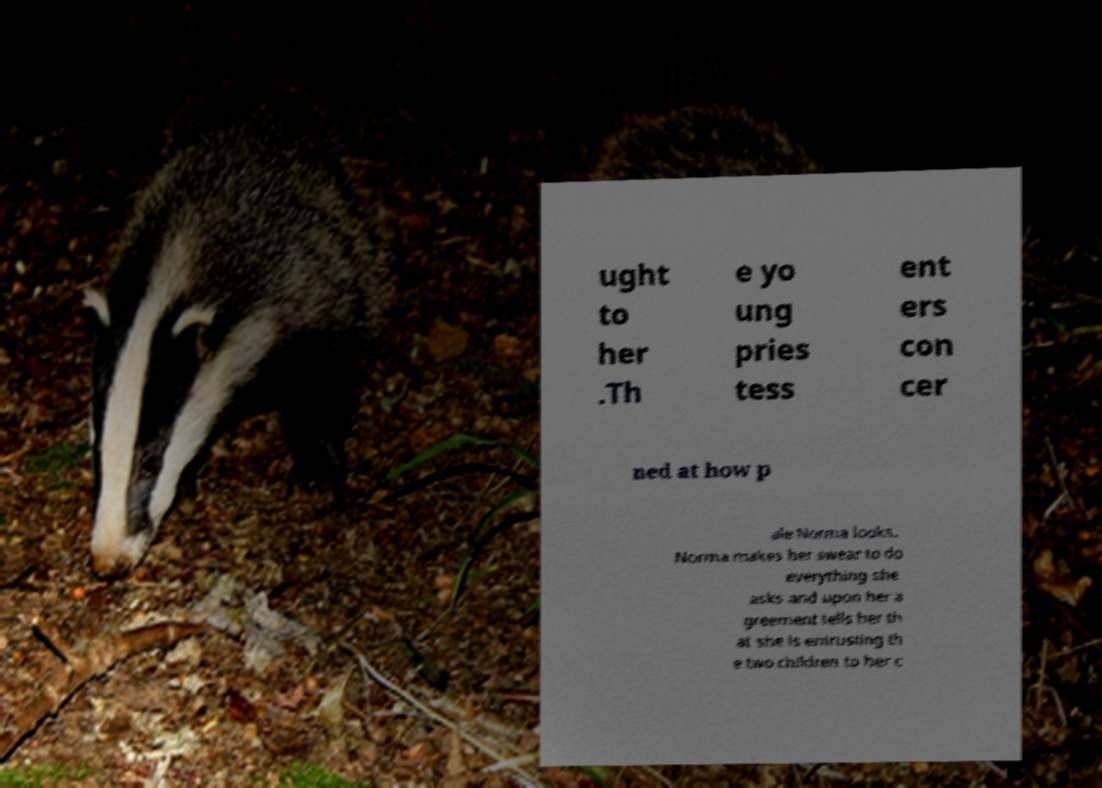Could you assist in decoding the text presented in this image and type it out clearly? ught to her .Th e yo ung pries tess ent ers con cer ned at how p ale Norma looks. Norma makes her swear to do everything she asks and upon her a greement tells her th at she is entrusting th e two children to her c 